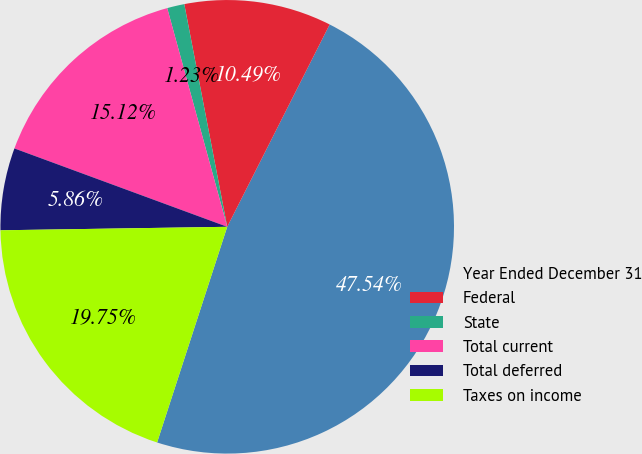<chart> <loc_0><loc_0><loc_500><loc_500><pie_chart><fcel>Year Ended December 31<fcel>Federal<fcel>State<fcel>Total current<fcel>Total deferred<fcel>Taxes on income<nl><fcel>47.54%<fcel>10.49%<fcel>1.23%<fcel>15.12%<fcel>5.86%<fcel>19.75%<nl></chart> 